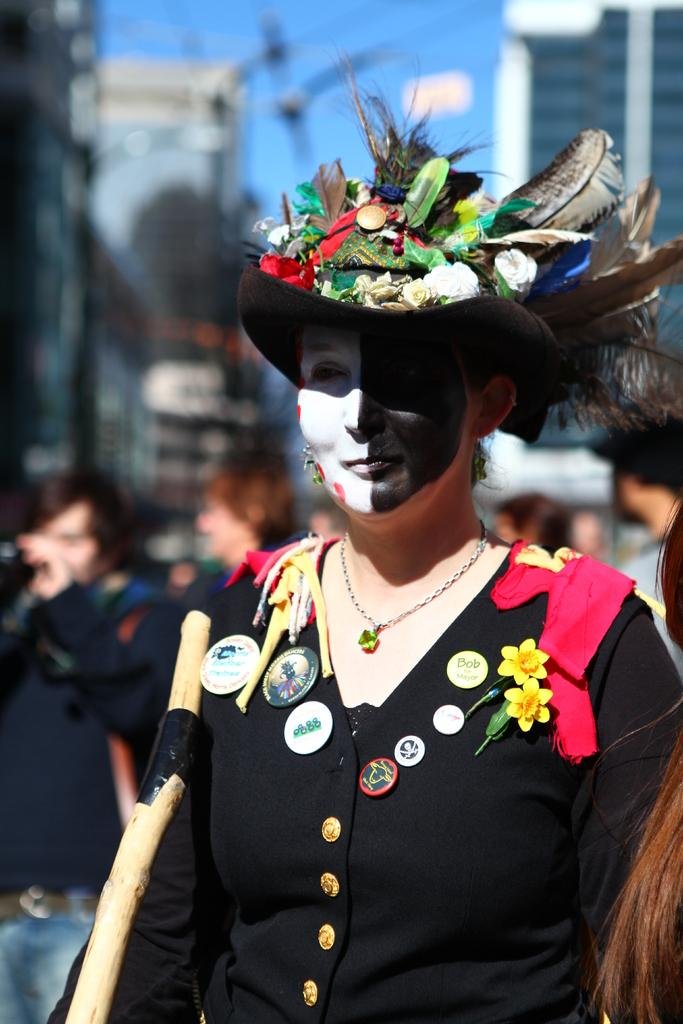What is the main subject of the image? There is a lady standing in the center of the image. What is the lady wearing? The lady is wearing a black dress. What is unique about the lady's appearance? There is a painting on the lady's face. What can be seen in the background of the image? There are people, buildings, and the sky visible in the background of the image. What type of thread is being used to create the clouds in the image? There are no clouds present in the image, so there is no thread being used to create them. 